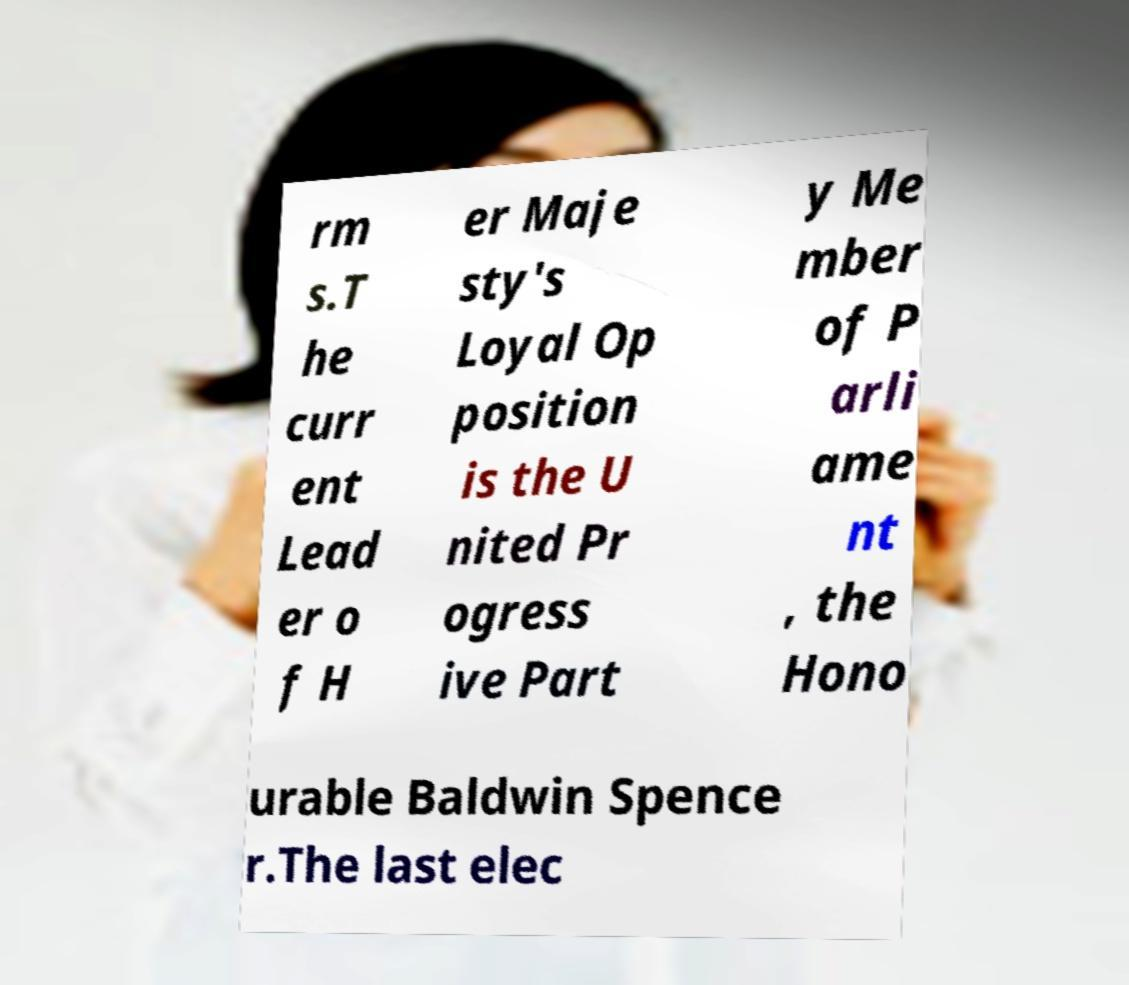I need the written content from this picture converted into text. Can you do that? rm s.T he curr ent Lead er o f H er Maje sty's Loyal Op position is the U nited Pr ogress ive Part y Me mber of P arli ame nt , the Hono urable Baldwin Spence r.The last elec 